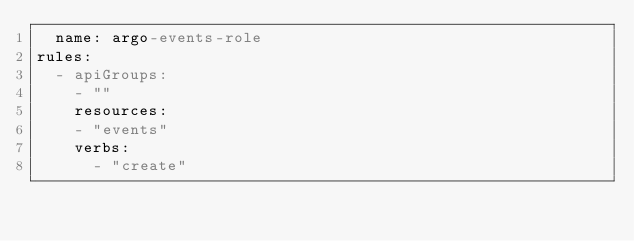Convert code to text. <code><loc_0><loc_0><loc_500><loc_500><_YAML_>  name: argo-events-role
rules:
  - apiGroups:
    - ""
    resources:
    - "events"
    verbs:
      - "create"</code> 